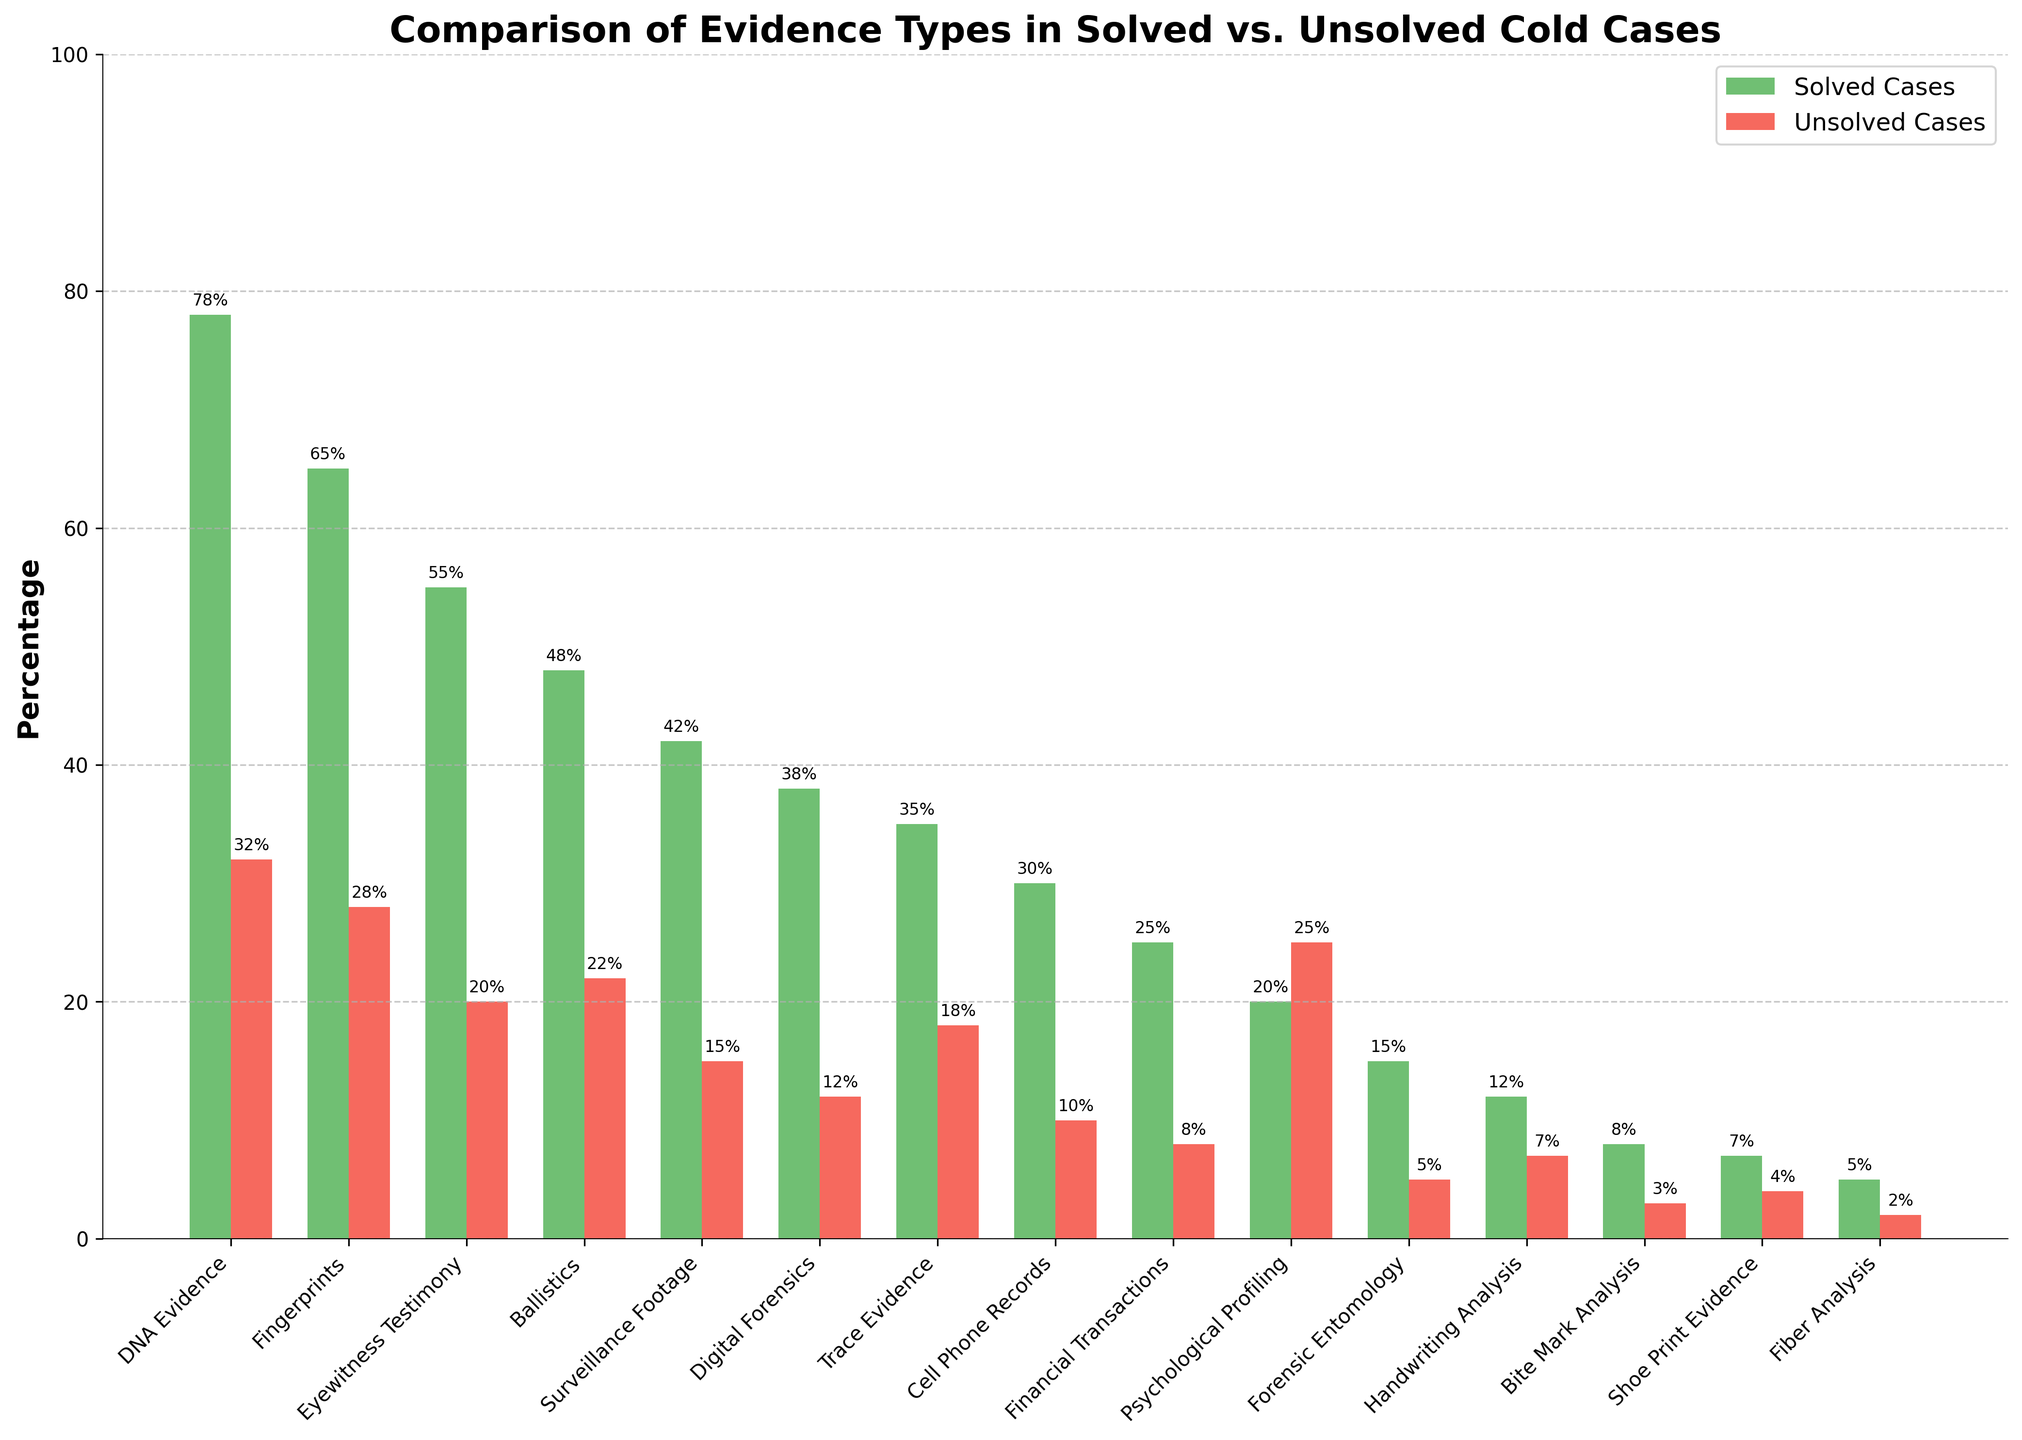Which evidence type has the highest percentage in solved cases? To determine the highest percentage evidence type in solved cases, look for the tallest green bar in the solved cases group. The DNA Evidence bar reaches the highest point at 78%.
Answer: DNA Evidence Which evidence type has a higher percentage in unsolved cases compared to solved cases? Compare the height of each red bar (unsolved cases) with the corresponding green bar (solved cases). Psychological Profiling has a higher percentage in unsolved cases (25%) compared to solved cases (20%).
Answer: Psychological Profiling What is the difference in percentage between solved and unsolved cases for Eyewitness Testimony? Find the height of Eyewitness Testimony bars for both solved and unsolved cases. The solved percentage is 55%, and the unsolved percentage is 20%. The difference is 55% - 20% = 35%.
Answer: 35% How many evidence types have a solved case percentage greater than 50%? Count the number of green bars that surpass the 50% mark. DNA Evidence, Fingerprints, and Eyewitness Testimony have percentages higher than 50%. This gives us a count of 3.
Answer: 3 What percentage of solved cases include Surveillance Footage evidence? Find the height of the green bar for Surveillance Footage. It reaches 42%.
Answer: 42% Is the percentage of unsolved cases with Financial Transactions evidence higher or lower than those with Cell Phone Records evidence? Compare the height of the red bars for Financial Transactions (8%) and Cell Phone Records (10%). The height for Cell Phone Records is higher.
Answer: Lower Which evidence type has the smallest difference in percentage between solved and unsolved cases? For each evidence type, compute the absolute difference between the solved and unsolved case percentages. Fiber Analysis has the smallest difference: 5% - 2% = 3%.
Answer: Fiber Analysis What is the combined percentage of solved cases for Digital Forensics and Trace Evidence? Add the percentages for Digital Forensics (38%) and Trace Evidence (35%). The combined percentage is 38% + 35% = 73%.
Answer: 73% Are there any evidence types where the percentage of solved cases is less than twice the percentage of unsolved cases? For each evidence type, check if the percentage of solved cases is less than twice the unsolved percentage. Surveillance Footage (42% solved, 15% unsolved) satisfies this: 42% < 2 * 15% = 30%.
Answer: Surveillance Footage What is the average percentage of solved cases for the first five evidence types listed? Sum the percentages for the first five evidence types: DNA Evidence (78%), Fingerprints (65%), Eyewitness Testimony (55%), Ballistics (48%), Surveillance Footage (42%). The sum is 78 + 65 + 55 + 48 + 42 = 288. Then, divide by 5 to get the average: 288 / 5 = 57.6%.
Answer: 57.6% 